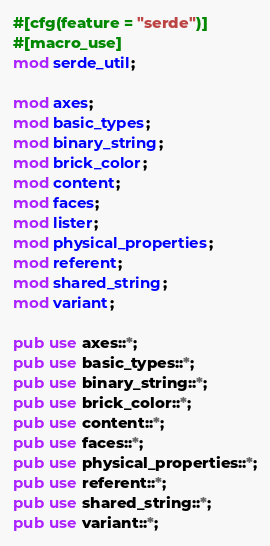Convert code to text. <code><loc_0><loc_0><loc_500><loc_500><_Rust_>#[cfg(feature = "serde")]
#[macro_use]
mod serde_util;

mod axes;
mod basic_types;
mod binary_string;
mod brick_color;
mod content;
mod faces;
mod lister;
mod physical_properties;
mod referent;
mod shared_string;
mod variant;

pub use axes::*;
pub use basic_types::*;
pub use binary_string::*;
pub use brick_color::*;
pub use content::*;
pub use faces::*;
pub use physical_properties::*;
pub use referent::*;
pub use shared_string::*;
pub use variant::*;
</code> 